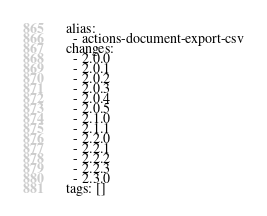Convert code to text. <code><loc_0><loc_0><loc_500><loc_500><_YAML_>alias:
  - actions-document-export-csv
changes:
  - 2.0.0
  - 2.0.1
  - 2.0.2
  - 2.0.3
  - 2.0.4
  - 2.0.5
  - 2.1.0
  - 2.1.1
  - 2.2.0
  - 2.2.1
  - 2.2.2
  - 2.2.3
  - 2.3.0
tags: []
</code> 